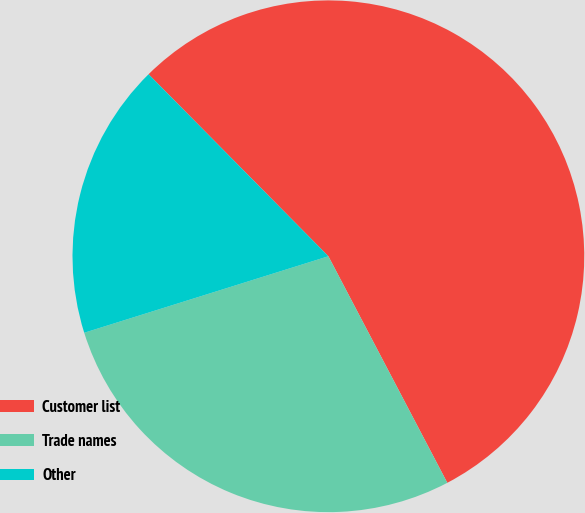Convert chart. <chart><loc_0><loc_0><loc_500><loc_500><pie_chart><fcel>Customer list<fcel>Trade names<fcel>Other<nl><fcel>54.71%<fcel>27.86%<fcel>17.43%<nl></chart> 